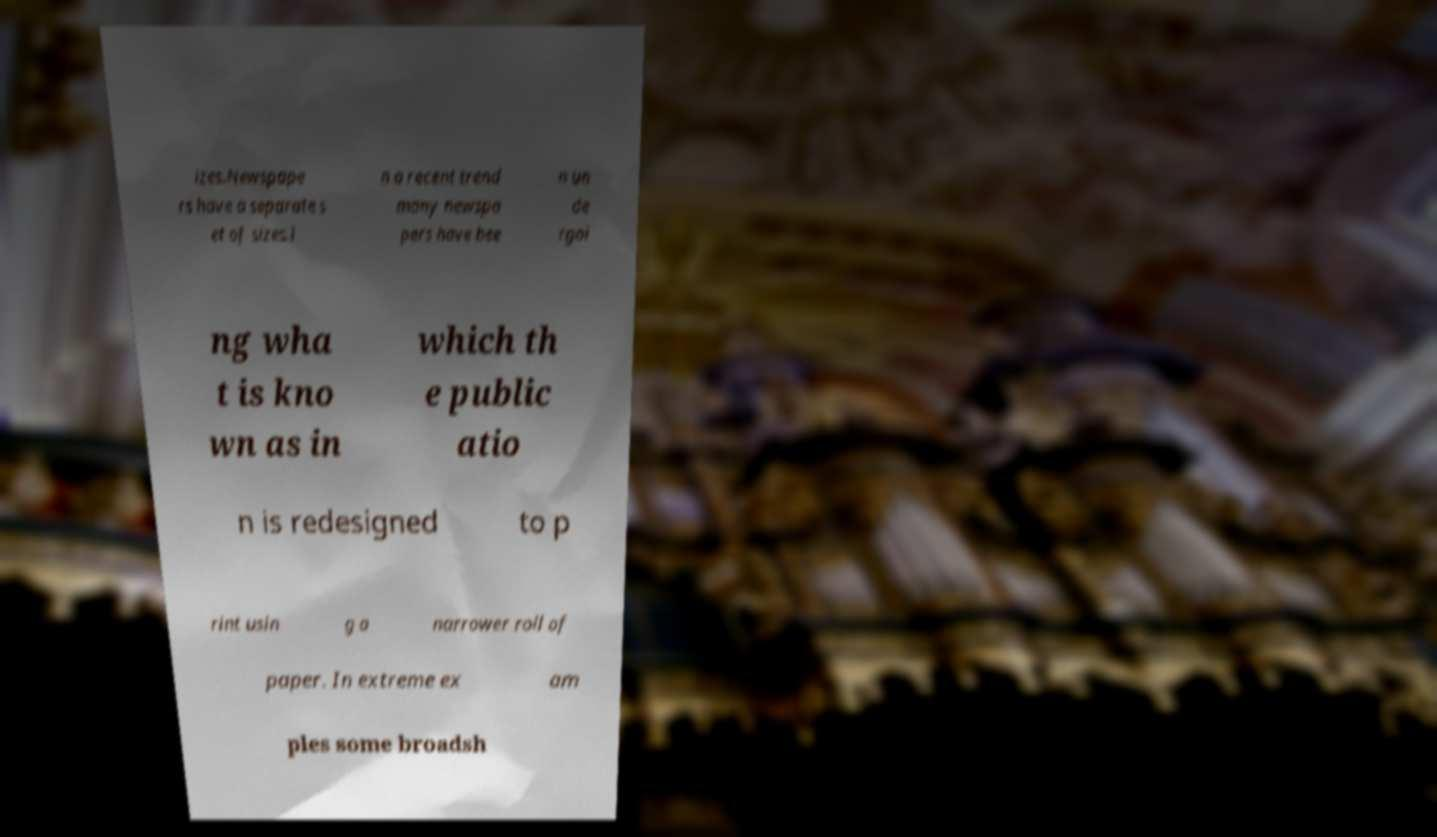Could you assist in decoding the text presented in this image and type it out clearly? izes.Newspape rs have a separate s et of sizes.I n a recent trend many newspa pers have bee n un de rgoi ng wha t is kno wn as in which th e public atio n is redesigned to p rint usin g a narrower roll of paper. In extreme ex am ples some broadsh 